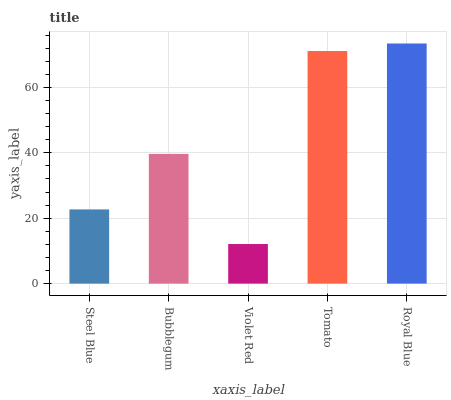Is Violet Red the minimum?
Answer yes or no. Yes. Is Royal Blue the maximum?
Answer yes or no. Yes. Is Bubblegum the minimum?
Answer yes or no. No. Is Bubblegum the maximum?
Answer yes or no. No. Is Bubblegum greater than Steel Blue?
Answer yes or no. Yes. Is Steel Blue less than Bubblegum?
Answer yes or no. Yes. Is Steel Blue greater than Bubblegum?
Answer yes or no. No. Is Bubblegum less than Steel Blue?
Answer yes or no. No. Is Bubblegum the high median?
Answer yes or no. Yes. Is Bubblegum the low median?
Answer yes or no. Yes. Is Violet Red the high median?
Answer yes or no. No. Is Steel Blue the low median?
Answer yes or no. No. 